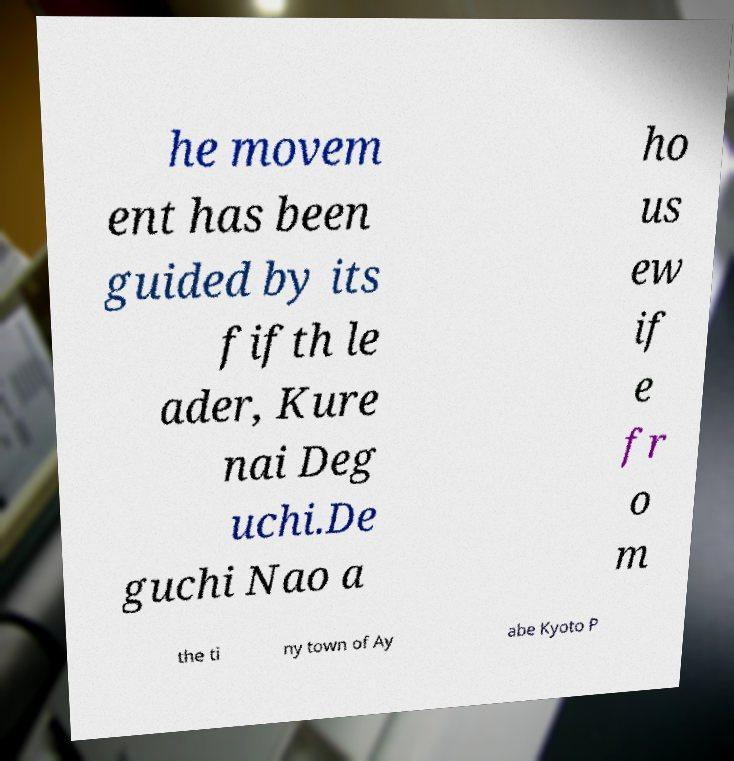Could you assist in decoding the text presented in this image and type it out clearly? he movem ent has been guided by its fifth le ader, Kure nai Deg uchi.De guchi Nao a ho us ew if e fr o m the ti ny town of Ay abe Kyoto P 